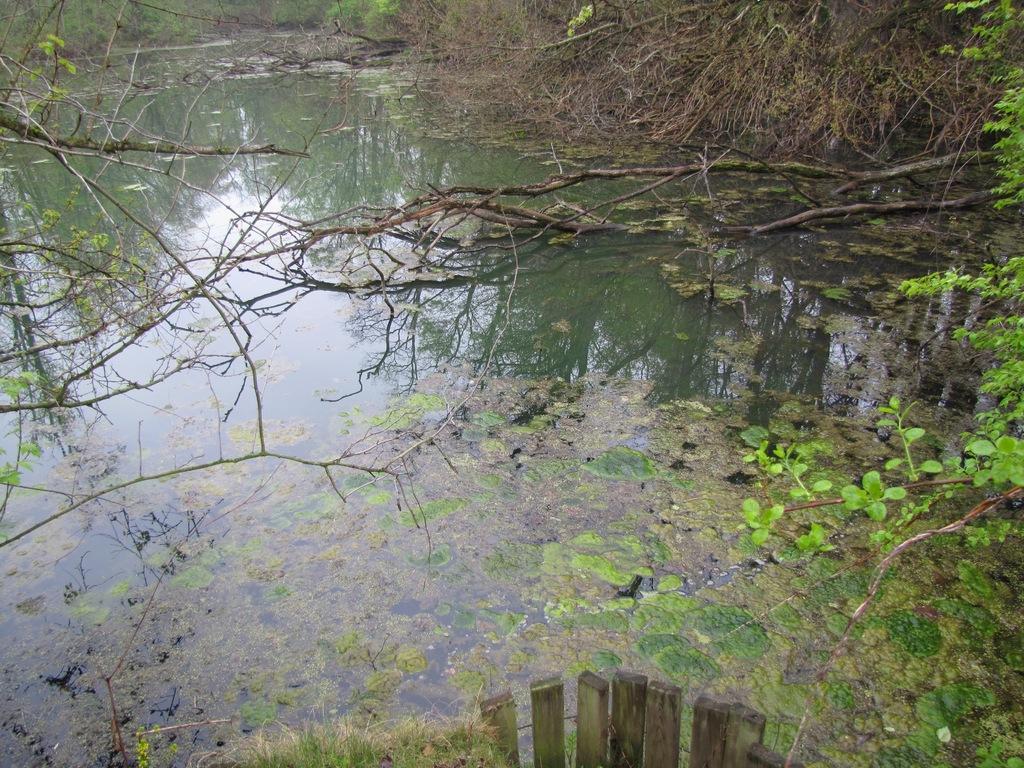Could you give a brief overview of what you see in this image? This image is taken outdoors. At the bottom of the image there is a wooden fence. In the middle of the image there is a pond with water. In the background there are a few trees and plants. 